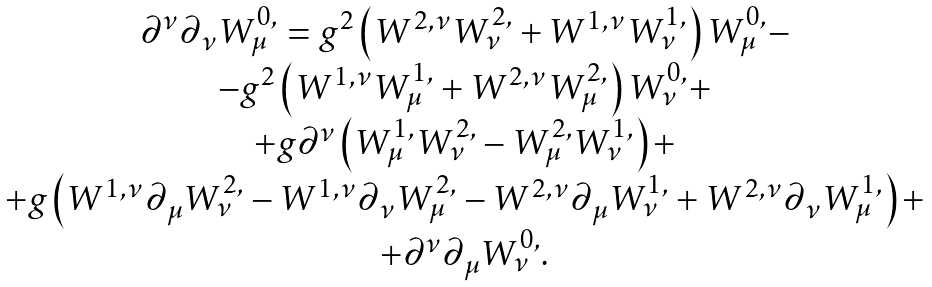Convert formula to latex. <formula><loc_0><loc_0><loc_500><loc_500>\begin{array} { c } \partial ^ { \nu } \partial _ { \nu } W _ { \mu } ^ { 0 , } = g ^ { 2 } \left ( W ^ { 2 , \nu } W _ { \nu } ^ { 2 , } + W ^ { 1 , \nu } W _ { \nu } ^ { 1 , } \right ) W _ { \mu } ^ { 0 , } - \\ - g ^ { 2 } \left ( W ^ { 1 , \nu } W _ { \mu } ^ { 1 , } + W ^ { 2 , \nu } W _ { \mu } ^ { 2 , } \right ) W _ { \nu } ^ { 0 , } + \\ + g \partial ^ { \nu } \left ( W _ { \mu } ^ { 1 , } W _ { \nu } ^ { 2 , } - W _ { \mu } ^ { 2 , } W _ { \nu } ^ { 1 , } \right ) + \\ + g \left ( W ^ { 1 , \nu } \partial _ { \mu } W _ { \nu } ^ { 2 , } - W ^ { 1 , \nu } \partial _ { \nu } W _ { \mu } ^ { 2 , } - W ^ { 2 , \nu } \partial _ { \mu } W _ { \nu } ^ { 1 , } + W ^ { 2 , \nu } \partial _ { \nu } W _ { \mu } ^ { 1 , } \right ) + \\ + \partial ^ { \nu } \partial _ { \mu } W _ { \nu } ^ { 0 , } . \end{array}</formula> 